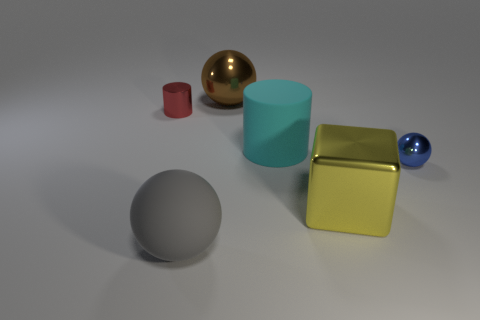Add 1 tiny blue matte cylinders. How many objects exist? 7 Subtract 1 cylinders. How many cylinders are left? 1 Add 4 large brown shiny cylinders. How many large brown shiny cylinders exist? 4 Subtract all red cylinders. How many cylinders are left? 1 Subtract all big spheres. How many spheres are left? 1 Subtract 1 yellow blocks. How many objects are left? 5 Subtract all cubes. How many objects are left? 5 Subtract all brown balls. Subtract all green cubes. How many balls are left? 2 Subtract all brown cylinders. How many gray blocks are left? 0 Subtract all green matte cylinders. Subtract all small objects. How many objects are left? 4 